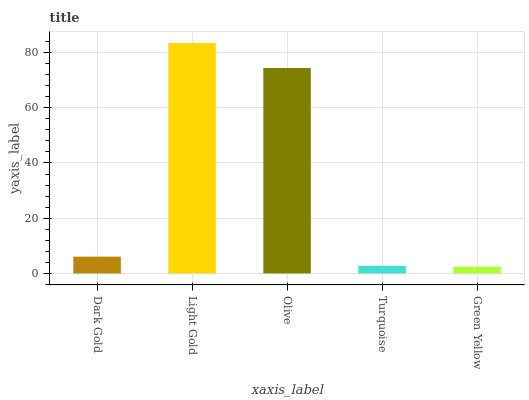Is Green Yellow the minimum?
Answer yes or no. Yes. Is Light Gold the maximum?
Answer yes or no. Yes. Is Olive the minimum?
Answer yes or no. No. Is Olive the maximum?
Answer yes or no. No. Is Light Gold greater than Olive?
Answer yes or no. Yes. Is Olive less than Light Gold?
Answer yes or no. Yes. Is Olive greater than Light Gold?
Answer yes or no. No. Is Light Gold less than Olive?
Answer yes or no. No. Is Dark Gold the high median?
Answer yes or no. Yes. Is Dark Gold the low median?
Answer yes or no. Yes. Is Light Gold the high median?
Answer yes or no. No. Is Green Yellow the low median?
Answer yes or no. No. 